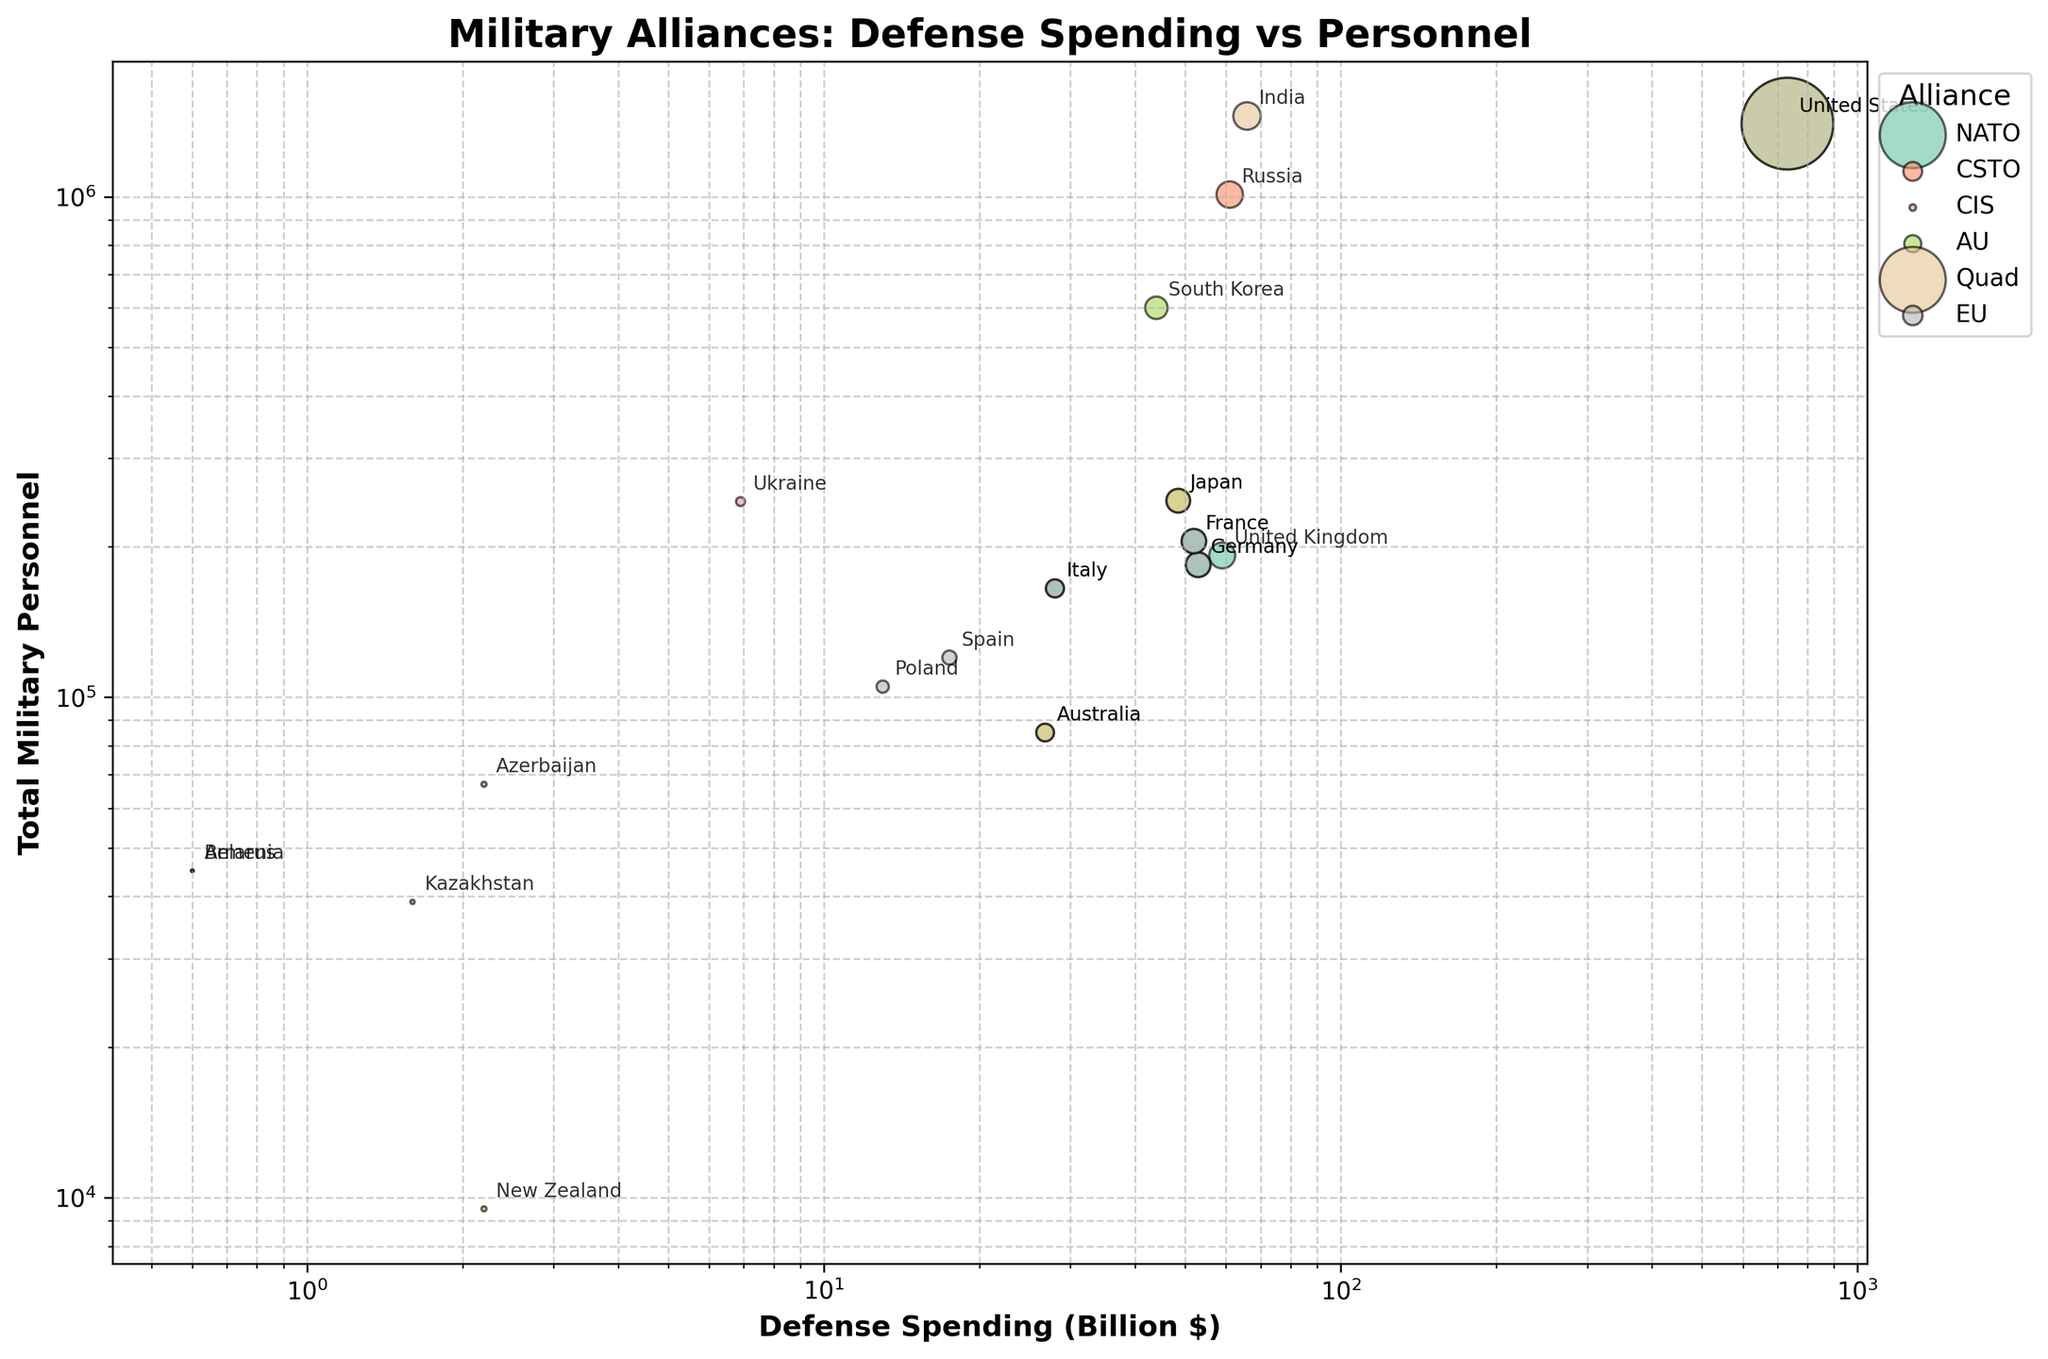What is the title of the bubble chart? The bubble chart's title is located at the top center of the figure and is specified within the code. It clearly states the main subject of the chart.
Answer: Military Alliances: Defense Spending vs Personnel How many data points represent the countries under the NATO alliance? To determine the number of data points for the NATO alliance, locate all the countries labeled as NATO in the legend and count them.
Answer: 5 Which country has the highest defense spending and in which alliance is it? Identify the bubble positioned farthest to the right since x-axis represents defense spending, then check its corresponding country and alliance name.
Answer: United States, NATO What is the defense spending of Australia within the Quad alliance? Find the bubbles associated with the Quad alliance in the legend, then look for the bubble labeled Australia. Match its position on the x-axis to find the defense spending.
Answer: 26.8 Billion $ Which alliance includes countries with both the lowest and highest defense spending? Compare all the alliances to find one that includes both United States (highest) and a country with very low spending.
Answer: Quad Which country in the Europe region has the smallest military personnel, and what is its defense spending? Locate the bubbles representing European countries, then identify the one with the smallest y-axis value. Check its coordinates for both personnel and spending.
Answer: Spain, 17.5 Billion $ How does the defense spending of France compare between the NATO and EU alliances? Identify France's bubbles in both NATO and EU alliances, then check if both are labeled the same defense spending.
Answer: Equal Which region has the majority of its countries under the NATO alliance? Count the number of bubbles labeled as NATO for each region and identify the region with the highest count.
Answer: Europe What is the size relationship between the bubbles representing total military personnel for the United States and India? Compare the size of the bubbles for the United States and India since size represents defense spending. Analyze the bubbles to determine if one is larger or if they are similar.
Answer: United States bubble is larger than India's 